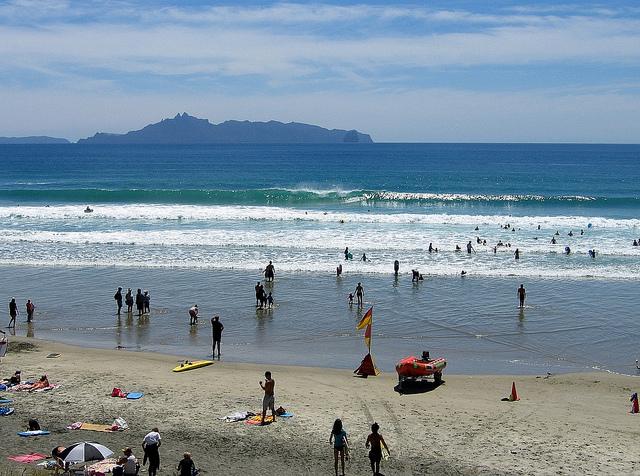Are the people in the background of the photo wet?
Give a very brief answer. Yes. What are the things floating above the water?
Short answer required. People. Are people swimming?
Answer briefly. Yes. How many umbrellas are in this photo?
Write a very short answer. 1. 